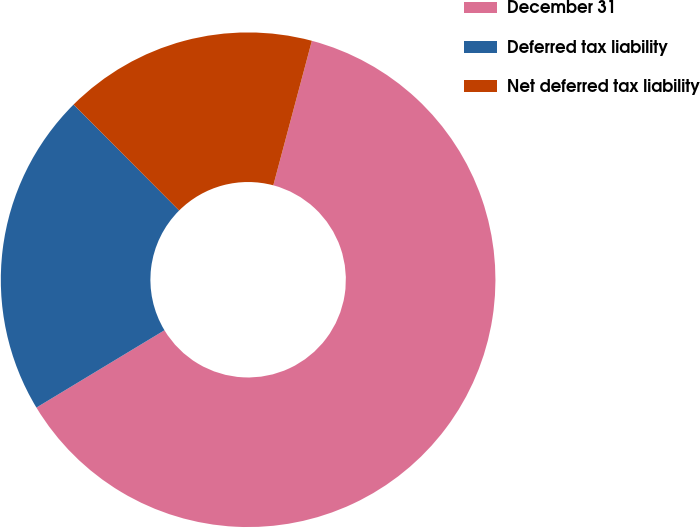Convert chart. <chart><loc_0><loc_0><loc_500><loc_500><pie_chart><fcel>December 31<fcel>Deferred tax liability<fcel>Net deferred tax liability<nl><fcel>62.21%<fcel>21.18%<fcel>16.62%<nl></chart> 